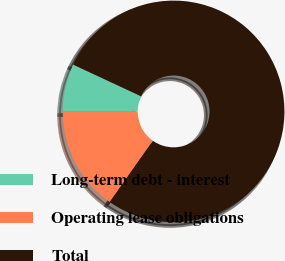<chart> <loc_0><loc_0><loc_500><loc_500><pie_chart><fcel>Long-term debt - interest<fcel>Operating lease obligations<fcel>Total<nl><fcel>6.93%<fcel>15.25%<fcel>77.82%<nl></chart> 